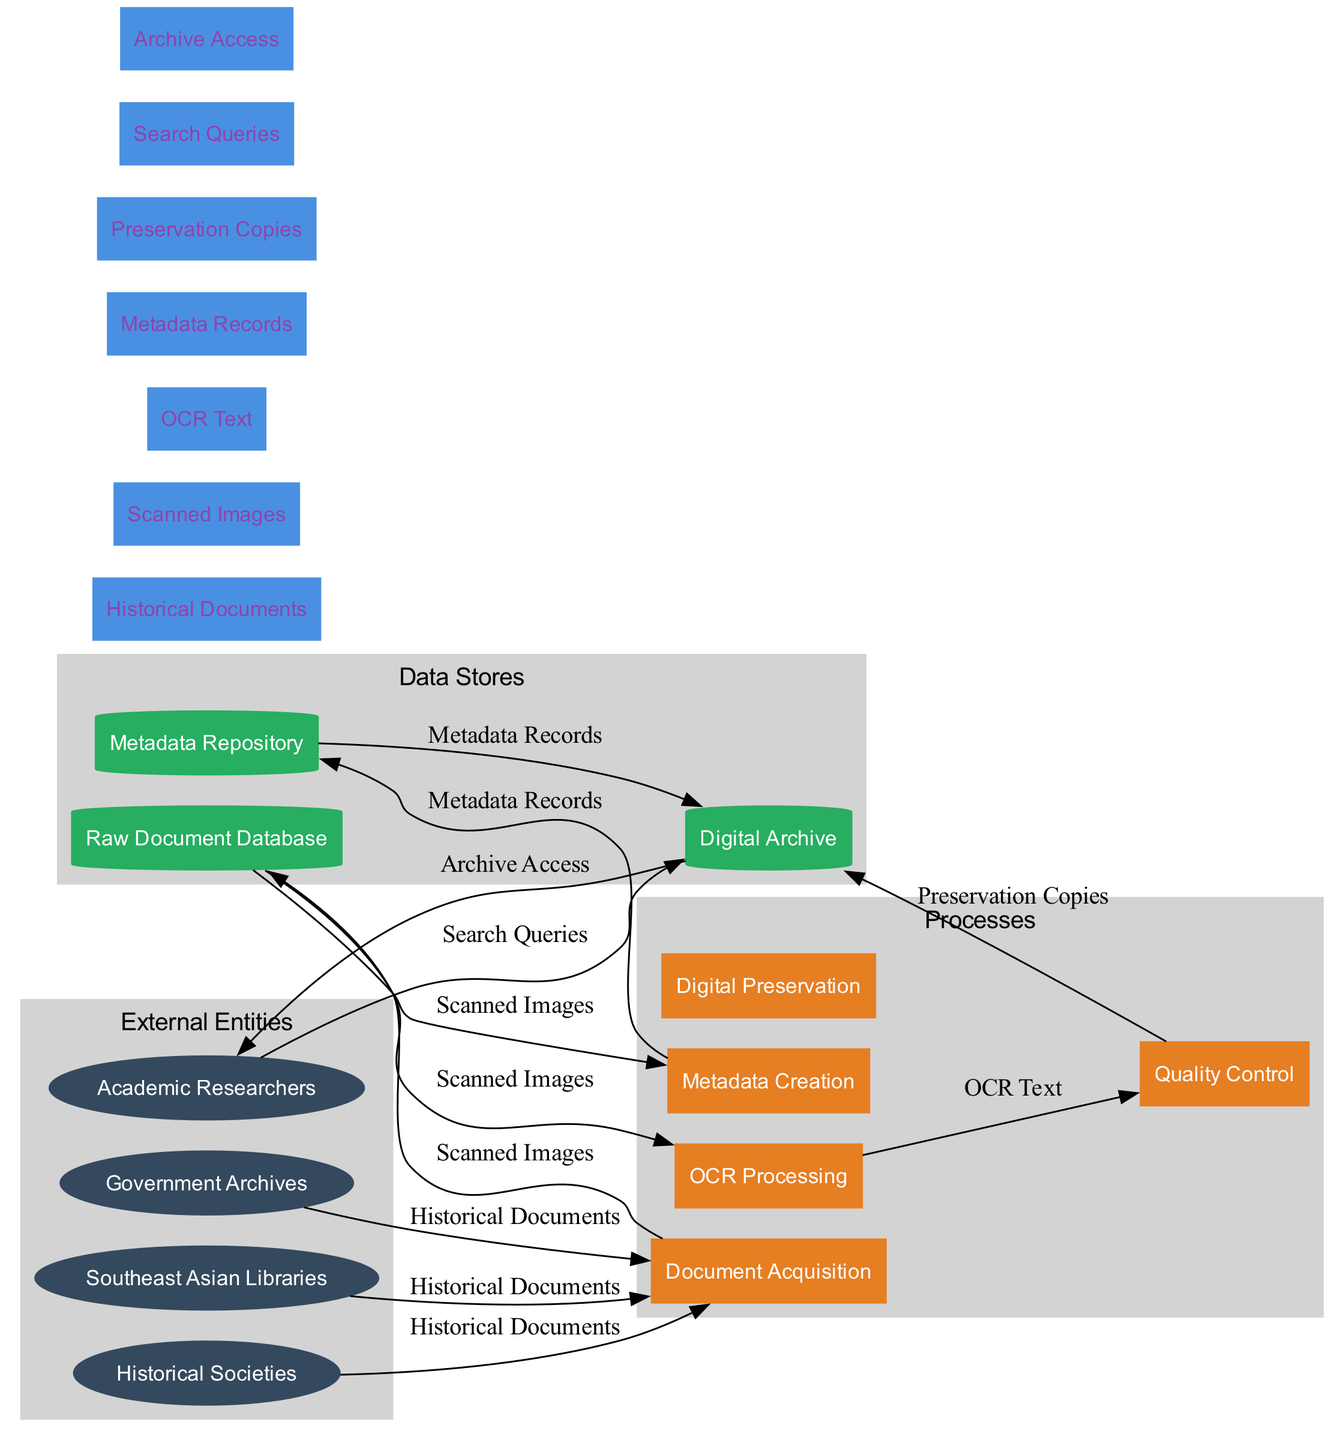What are the external entities in this diagram? The diagram lists four external entities: Southeast Asian Libraries, Historical Societies, Academic Researchers, and Government Archives. These represent the organizations involved in the digital archive creation process.
Answer: Southeast Asian Libraries, Historical Societies, Academic Researchers, Government Archives How many processes are there in the diagram? There are five processes listed in the diagram: Document Acquisition, Metadata Creation, OCR Processing, Quality Control, and Digital Preservation. Counting these processes gives the total of five.
Answer: 5 What flow occurs between the Document Acquisition and Raw Document Database? The flow between Document Acquisition and Raw Document Database is “Scanned Images”. This indicates that scanned images of historical documents are stored in the raw document database as a result of the document acquisition process.
Answer: Scanned Images Which data store receives data from Quality Control? The data store that receives data from Quality Control is the Digital Archive. After quality control, preservation copies are sent to the digital archive for safekeeping.
Answer: Digital Archive What is the role of Academic Researchers according to the diagram? Academic Researchers interact with the Digital Archive by sending "Search Queries" to access historical documents and data. This indicates their role in researching and utilizing the digital resources available.
Answer: Search Queries How many data flows are present in the diagram? The diagram depicts six data flows: Historical Documents, Scanned Images, OCR Text, Metadata Records, Preservation Copies, and Search Queries. Counting these results in a total of six data flows.
Answer: 6 What type of data store is the Metadata Repository? The Metadata Repository is classified as a data store in the diagram and is depicted as a cylinder, which typically represents data storage in data flow diagrams. This type is specifically for storing metadata records related to the documents.
Answer: cylinder Which process comes before OCR Processing in the flow? The process that comes before OCR Processing is Raw Document Database. The scanned images from the raw document database are subsequently sent to the OCR Processing step for text recognition.
Answer: Raw Document Database What type of flow is represented between Metadata Repository and Digital Archive? The flow represented between Metadata Repository and Digital Archive is "Metadata Records". This shows that metadata created during the metadata creation process is stored within the digital archive for better document management.
Answer: Metadata Records 